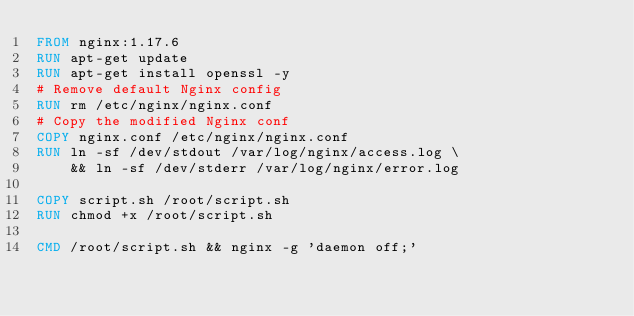<code> <loc_0><loc_0><loc_500><loc_500><_Dockerfile_>FROM nginx:1.17.6
RUN apt-get update
RUN apt-get install openssl -y
# Remove default Nginx config
RUN rm /etc/nginx/nginx.conf
# Copy the modified Nginx conf
COPY nginx.conf /etc/nginx/nginx.conf
RUN ln -sf /dev/stdout /var/log/nginx/access.log \
    && ln -sf /dev/stderr /var/log/nginx/error.log

COPY script.sh /root/script.sh
RUN chmod +x /root/script.sh

CMD /root/script.sh && nginx -g 'daemon off;'</code> 